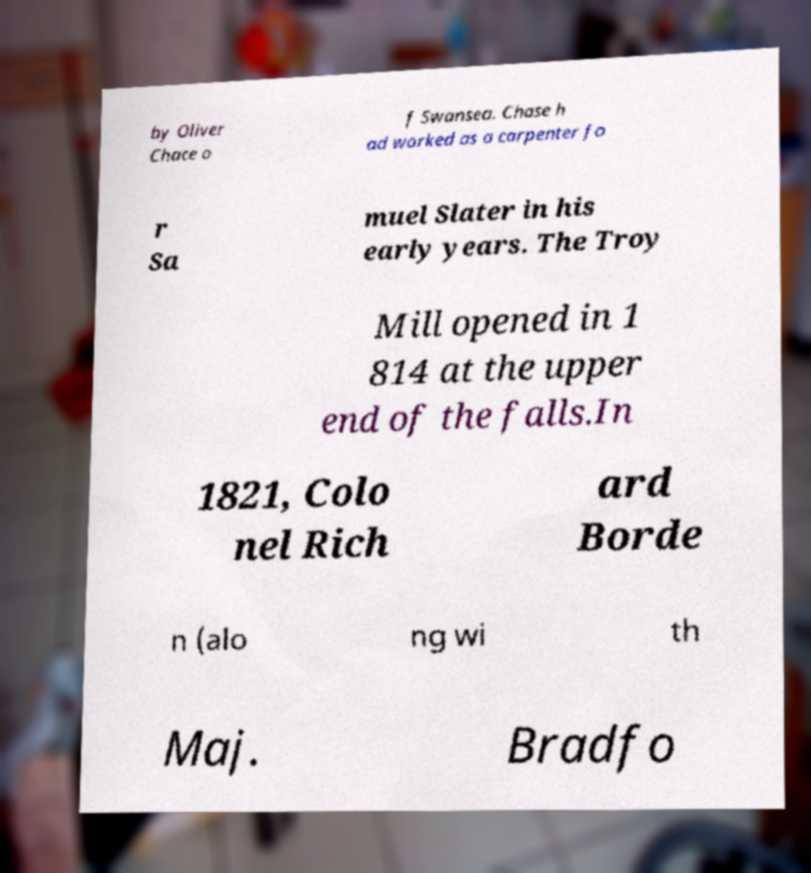There's text embedded in this image that I need extracted. Can you transcribe it verbatim? by Oliver Chace o f Swansea. Chase h ad worked as a carpenter fo r Sa muel Slater in his early years. The Troy Mill opened in 1 814 at the upper end of the falls.In 1821, Colo nel Rich ard Borde n (alo ng wi th Maj. Bradfo 